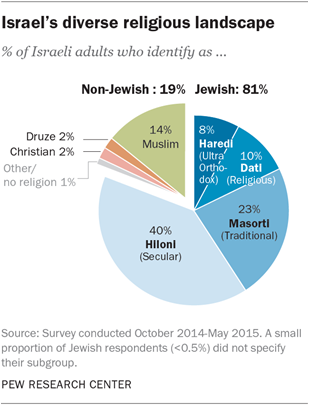Outline some significant characteristics in this image. In Israel, about 14% of adults identify as Muslim. I want to know the sum of all the segments with values below 10, starting from 5. 